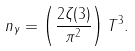Convert formula to latex. <formula><loc_0><loc_0><loc_500><loc_500>n _ { \gamma } = \left ( \frac { 2 \zeta ( 3 ) } { \pi ^ { 2 } } \right ) T ^ { 3 } .</formula> 